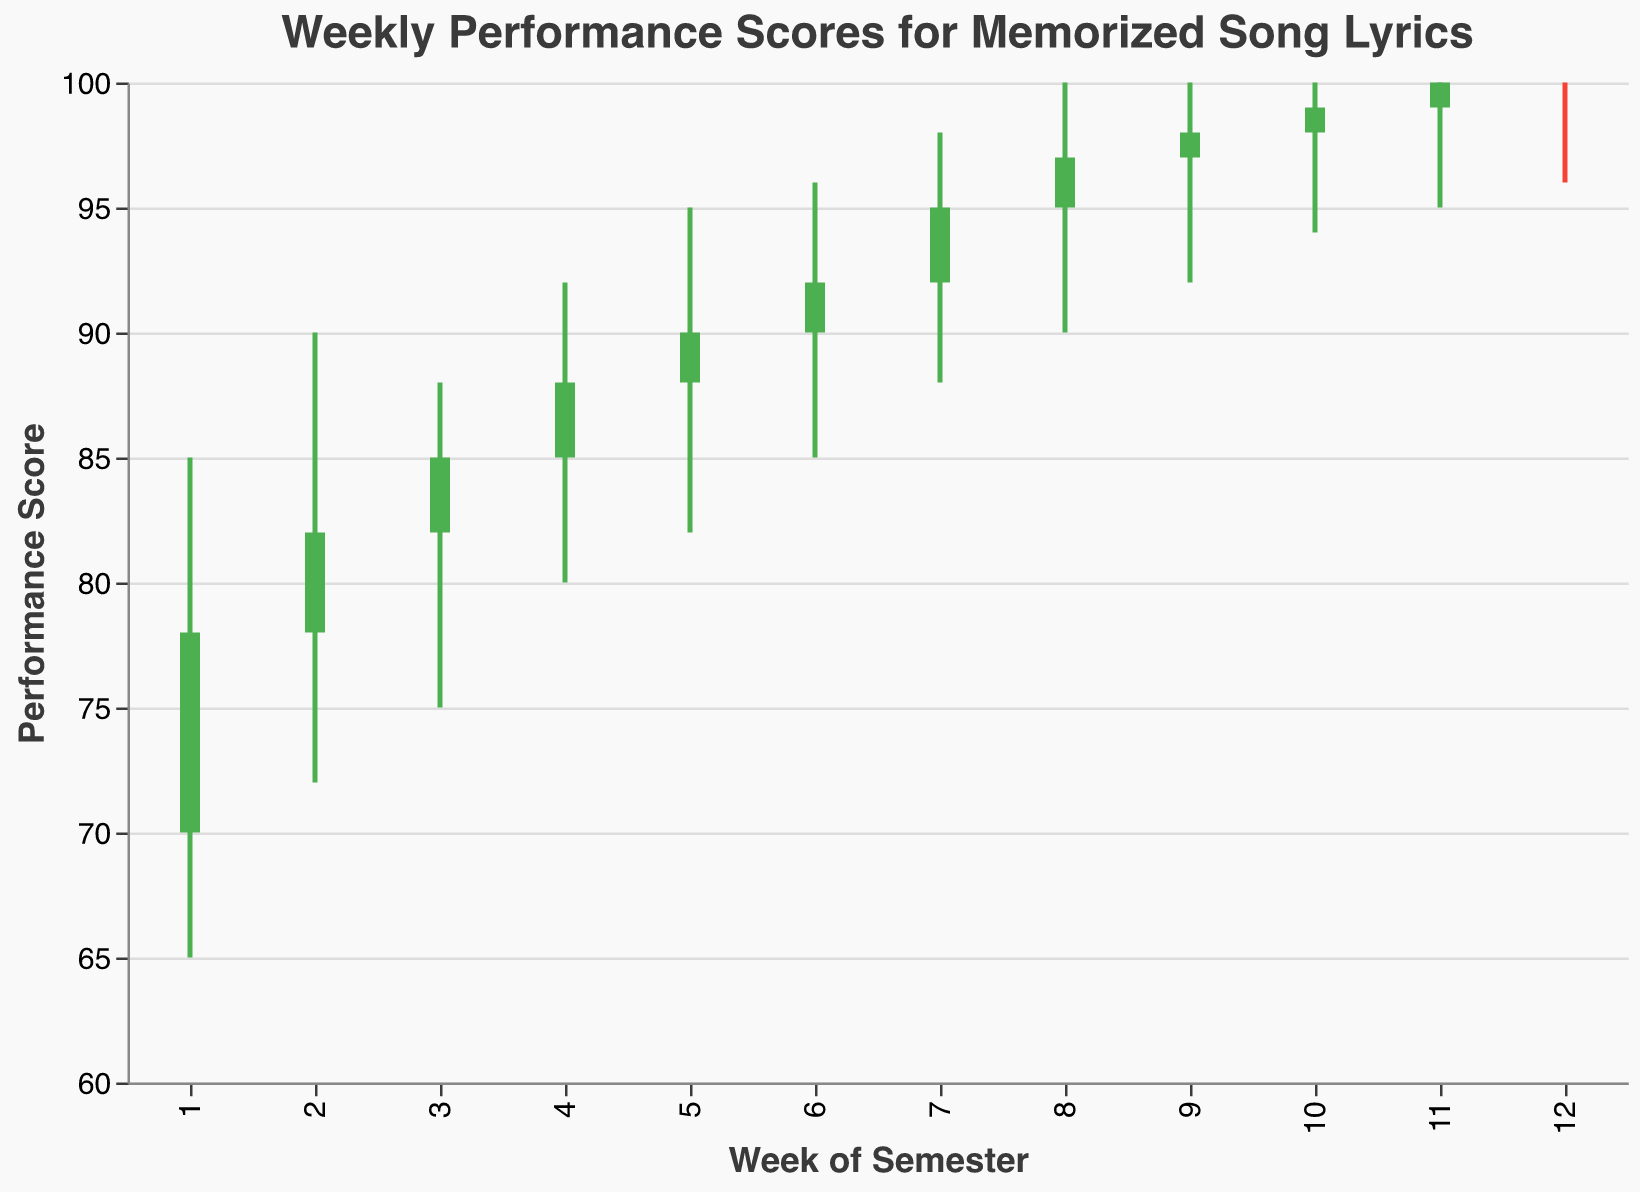What week did the performance score open the highest? Looking at the "Open" values, the highest opening score is 100, which occurs in Week 12.
Answer: Week 12 What is the lowest performance score recorded during the semester? To find the lowest score, we look at the "Low" values. The lowest recorded score is 65 in Week 1.
Answer: 65 In which weeks did the performance score increase from the opening to the closing value? A score increase occurs if the closing value is higher than the opening value. Weeks 1, 2, 3, 4, 5, 6, 7, 8, 9, and 10 show this increase. Weeks 11 and 12 have equal opening and closing values.
Answer: Weeks 1-10 What is the overall percentage increase in the performance score from Week 1 to Week 12? The percentage increase is calculated as ((Close Week 12 - Open Week 1) / Open Week 1) * 100. Thus, ((100 - 70) / 70) * 100 = 42.86%.
Answer: 42.86% Which week shows the highest fluctuation in performance score? Fluctuation can be assessed by the range "High - Low". The largest range is for Week 7 and Week 8, with a difference of 10.
Answer: Weeks 7 and 8 By how much did the performance score increase from Week 5 to Week 6? Subtract Week 5's closing value from Week 6's closing value: 92 - 90 = 2.
Answer: 2 Which week had the smallest difference between its high and low values? The smallest difference between high and low is found by calculating the range for each week. Week 11 and Week 12 both have a range of 4.
Answer: Weeks 11 and 12 What was the closing performance score on Week 9? Simply look at the closing value for Week 9, which is 98.
Answer: 98 On which week did the performance score reach its maximum high value? The maximum "High" value is 100, first reached in Week 8 and continues to Week 12.
Answer: Week 8 What is the average closing performance score for the entire semester? Sum all closing scores and divide by 12: (78 + 82 + 85 + 88 + 90 + 92 + 95 + 97 + 98 + 99 + 100 + 100) / 12 = 91.33.
Answer: 91.33 